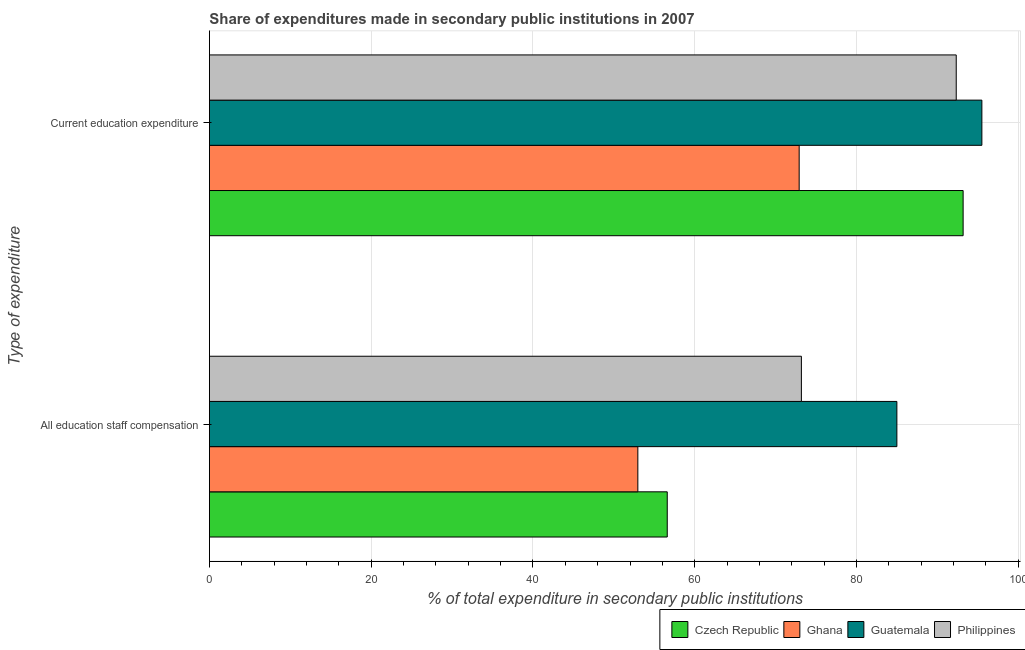Are the number of bars on each tick of the Y-axis equal?
Your response must be concise. Yes. How many bars are there on the 2nd tick from the top?
Your answer should be compact. 4. What is the label of the 2nd group of bars from the top?
Offer a very short reply. All education staff compensation. What is the expenditure in staff compensation in Czech Republic?
Your response must be concise. 56.6. Across all countries, what is the maximum expenditure in education?
Ensure brevity in your answer.  95.5. Across all countries, what is the minimum expenditure in education?
Your answer should be very brief. 72.91. In which country was the expenditure in staff compensation maximum?
Provide a succinct answer. Guatemala. What is the total expenditure in staff compensation in the graph?
Give a very brief answer. 267.74. What is the difference between the expenditure in education in Philippines and that in Ghana?
Keep it short and to the point. 19.42. What is the difference between the expenditure in staff compensation in Ghana and the expenditure in education in Czech Republic?
Keep it short and to the point. -40.22. What is the average expenditure in staff compensation per country?
Ensure brevity in your answer.  66.93. What is the difference between the expenditure in education and expenditure in staff compensation in Guatemala?
Your response must be concise. 10.51. What is the ratio of the expenditure in education in Philippines to that in Guatemala?
Your answer should be compact. 0.97. Is the expenditure in education in Guatemala less than that in Czech Republic?
Give a very brief answer. No. In how many countries, is the expenditure in education greater than the average expenditure in education taken over all countries?
Provide a succinct answer. 3. What does the 4th bar from the top in All education staff compensation represents?
Your response must be concise. Czech Republic. What does the 2nd bar from the bottom in Current education expenditure represents?
Offer a very short reply. Ghana. How many bars are there?
Offer a terse response. 8. What is the difference between two consecutive major ticks on the X-axis?
Provide a short and direct response. 20. Does the graph contain grids?
Your answer should be very brief. Yes. Where does the legend appear in the graph?
Ensure brevity in your answer.  Bottom right. How many legend labels are there?
Make the answer very short. 4. How are the legend labels stacked?
Make the answer very short. Horizontal. What is the title of the graph?
Offer a terse response. Share of expenditures made in secondary public institutions in 2007. What is the label or title of the X-axis?
Ensure brevity in your answer.  % of total expenditure in secondary public institutions. What is the label or title of the Y-axis?
Give a very brief answer. Type of expenditure. What is the % of total expenditure in secondary public institutions in Czech Republic in All education staff compensation?
Give a very brief answer. 56.6. What is the % of total expenditure in secondary public institutions of Ghana in All education staff compensation?
Provide a short and direct response. 52.97. What is the % of total expenditure in secondary public institutions of Guatemala in All education staff compensation?
Your answer should be compact. 84.99. What is the % of total expenditure in secondary public institutions in Philippines in All education staff compensation?
Offer a very short reply. 73.18. What is the % of total expenditure in secondary public institutions in Czech Republic in Current education expenditure?
Keep it short and to the point. 93.18. What is the % of total expenditure in secondary public institutions of Ghana in Current education expenditure?
Make the answer very short. 72.91. What is the % of total expenditure in secondary public institutions in Guatemala in Current education expenditure?
Give a very brief answer. 95.5. What is the % of total expenditure in secondary public institutions in Philippines in Current education expenditure?
Make the answer very short. 92.33. Across all Type of expenditure, what is the maximum % of total expenditure in secondary public institutions in Czech Republic?
Make the answer very short. 93.18. Across all Type of expenditure, what is the maximum % of total expenditure in secondary public institutions in Ghana?
Your answer should be compact. 72.91. Across all Type of expenditure, what is the maximum % of total expenditure in secondary public institutions in Guatemala?
Provide a short and direct response. 95.5. Across all Type of expenditure, what is the maximum % of total expenditure in secondary public institutions of Philippines?
Your response must be concise. 92.33. Across all Type of expenditure, what is the minimum % of total expenditure in secondary public institutions in Czech Republic?
Ensure brevity in your answer.  56.6. Across all Type of expenditure, what is the minimum % of total expenditure in secondary public institutions of Ghana?
Your answer should be compact. 52.97. Across all Type of expenditure, what is the minimum % of total expenditure in secondary public institutions in Guatemala?
Your answer should be very brief. 84.99. Across all Type of expenditure, what is the minimum % of total expenditure in secondary public institutions in Philippines?
Keep it short and to the point. 73.18. What is the total % of total expenditure in secondary public institutions in Czech Republic in the graph?
Offer a terse response. 149.78. What is the total % of total expenditure in secondary public institutions of Ghana in the graph?
Offer a terse response. 125.87. What is the total % of total expenditure in secondary public institutions in Guatemala in the graph?
Provide a succinct answer. 180.49. What is the total % of total expenditure in secondary public institutions of Philippines in the graph?
Your response must be concise. 165.51. What is the difference between the % of total expenditure in secondary public institutions of Czech Republic in All education staff compensation and that in Current education expenditure?
Ensure brevity in your answer.  -36.58. What is the difference between the % of total expenditure in secondary public institutions in Ghana in All education staff compensation and that in Current education expenditure?
Provide a succinct answer. -19.94. What is the difference between the % of total expenditure in secondary public institutions of Guatemala in All education staff compensation and that in Current education expenditure?
Your answer should be compact. -10.51. What is the difference between the % of total expenditure in secondary public institutions in Philippines in All education staff compensation and that in Current education expenditure?
Ensure brevity in your answer.  -19.14. What is the difference between the % of total expenditure in secondary public institutions in Czech Republic in All education staff compensation and the % of total expenditure in secondary public institutions in Ghana in Current education expenditure?
Keep it short and to the point. -16.31. What is the difference between the % of total expenditure in secondary public institutions of Czech Republic in All education staff compensation and the % of total expenditure in secondary public institutions of Guatemala in Current education expenditure?
Your response must be concise. -38.9. What is the difference between the % of total expenditure in secondary public institutions in Czech Republic in All education staff compensation and the % of total expenditure in secondary public institutions in Philippines in Current education expenditure?
Provide a succinct answer. -35.73. What is the difference between the % of total expenditure in secondary public institutions of Ghana in All education staff compensation and the % of total expenditure in secondary public institutions of Guatemala in Current education expenditure?
Ensure brevity in your answer.  -42.53. What is the difference between the % of total expenditure in secondary public institutions of Ghana in All education staff compensation and the % of total expenditure in secondary public institutions of Philippines in Current education expenditure?
Provide a short and direct response. -39.36. What is the difference between the % of total expenditure in secondary public institutions in Guatemala in All education staff compensation and the % of total expenditure in secondary public institutions in Philippines in Current education expenditure?
Your answer should be very brief. -7.34. What is the average % of total expenditure in secondary public institutions in Czech Republic per Type of expenditure?
Your answer should be compact. 74.89. What is the average % of total expenditure in secondary public institutions of Ghana per Type of expenditure?
Your response must be concise. 62.94. What is the average % of total expenditure in secondary public institutions of Guatemala per Type of expenditure?
Your response must be concise. 90.24. What is the average % of total expenditure in secondary public institutions of Philippines per Type of expenditure?
Offer a terse response. 82.76. What is the difference between the % of total expenditure in secondary public institutions of Czech Republic and % of total expenditure in secondary public institutions of Ghana in All education staff compensation?
Make the answer very short. 3.64. What is the difference between the % of total expenditure in secondary public institutions in Czech Republic and % of total expenditure in secondary public institutions in Guatemala in All education staff compensation?
Offer a very short reply. -28.39. What is the difference between the % of total expenditure in secondary public institutions in Czech Republic and % of total expenditure in secondary public institutions in Philippines in All education staff compensation?
Provide a succinct answer. -16.58. What is the difference between the % of total expenditure in secondary public institutions in Ghana and % of total expenditure in secondary public institutions in Guatemala in All education staff compensation?
Make the answer very short. -32.02. What is the difference between the % of total expenditure in secondary public institutions in Ghana and % of total expenditure in secondary public institutions in Philippines in All education staff compensation?
Make the answer very short. -20.22. What is the difference between the % of total expenditure in secondary public institutions of Guatemala and % of total expenditure in secondary public institutions of Philippines in All education staff compensation?
Ensure brevity in your answer.  11.81. What is the difference between the % of total expenditure in secondary public institutions in Czech Republic and % of total expenditure in secondary public institutions in Ghana in Current education expenditure?
Offer a terse response. 20.27. What is the difference between the % of total expenditure in secondary public institutions of Czech Republic and % of total expenditure in secondary public institutions of Guatemala in Current education expenditure?
Provide a succinct answer. -2.32. What is the difference between the % of total expenditure in secondary public institutions of Czech Republic and % of total expenditure in secondary public institutions of Philippines in Current education expenditure?
Give a very brief answer. 0.85. What is the difference between the % of total expenditure in secondary public institutions of Ghana and % of total expenditure in secondary public institutions of Guatemala in Current education expenditure?
Offer a very short reply. -22.59. What is the difference between the % of total expenditure in secondary public institutions in Ghana and % of total expenditure in secondary public institutions in Philippines in Current education expenditure?
Keep it short and to the point. -19.42. What is the difference between the % of total expenditure in secondary public institutions in Guatemala and % of total expenditure in secondary public institutions in Philippines in Current education expenditure?
Offer a very short reply. 3.17. What is the ratio of the % of total expenditure in secondary public institutions in Czech Republic in All education staff compensation to that in Current education expenditure?
Ensure brevity in your answer.  0.61. What is the ratio of the % of total expenditure in secondary public institutions of Ghana in All education staff compensation to that in Current education expenditure?
Your answer should be very brief. 0.73. What is the ratio of the % of total expenditure in secondary public institutions of Guatemala in All education staff compensation to that in Current education expenditure?
Make the answer very short. 0.89. What is the ratio of the % of total expenditure in secondary public institutions of Philippines in All education staff compensation to that in Current education expenditure?
Keep it short and to the point. 0.79. What is the difference between the highest and the second highest % of total expenditure in secondary public institutions in Czech Republic?
Your answer should be very brief. 36.58. What is the difference between the highest and the second highest % of total expenditure in secondary public institutions in Ghana?
Your response must be concise. 19.94. What is the difference between the highest and the second highest % of total expenditure in secondary public institutions in Guatemala?
Keep it short and to the point. 10.51. What is the difference between the highest and the second highest % of total expenditure in secondary public institutions in Philippines?
Ensure brevity in your answer.  19.14. What is the difference between the highest and the lowest % of total expenditure in secondary public institutions of Czech Republic?
Your answer should be very brief. 36.58. What is the difference between the highest and the lowest % of total expenditure in secondary public institutions in Ghana?
Make the answer very short. 19.94. What is the difference between the highest and the lowest % of total expenditure in secondary public institutions in Guatemala?
Your answer should be very brief. 10.51. What is the difference between the highest and the lowest % of total expenditure in secondary public institutions of Philippines?
Give a very brief answer. 19.14. 